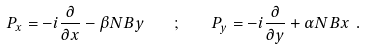<formula> <loc_0><loc_0><loc_500><loc_500>P _ { x } = - i \frac { \partial } { \partial x } - \beta N B y \quad ; \quad P _ { y } = - i \frac { \partial } { \partial y } + \alpha N B x \ .</formula> 